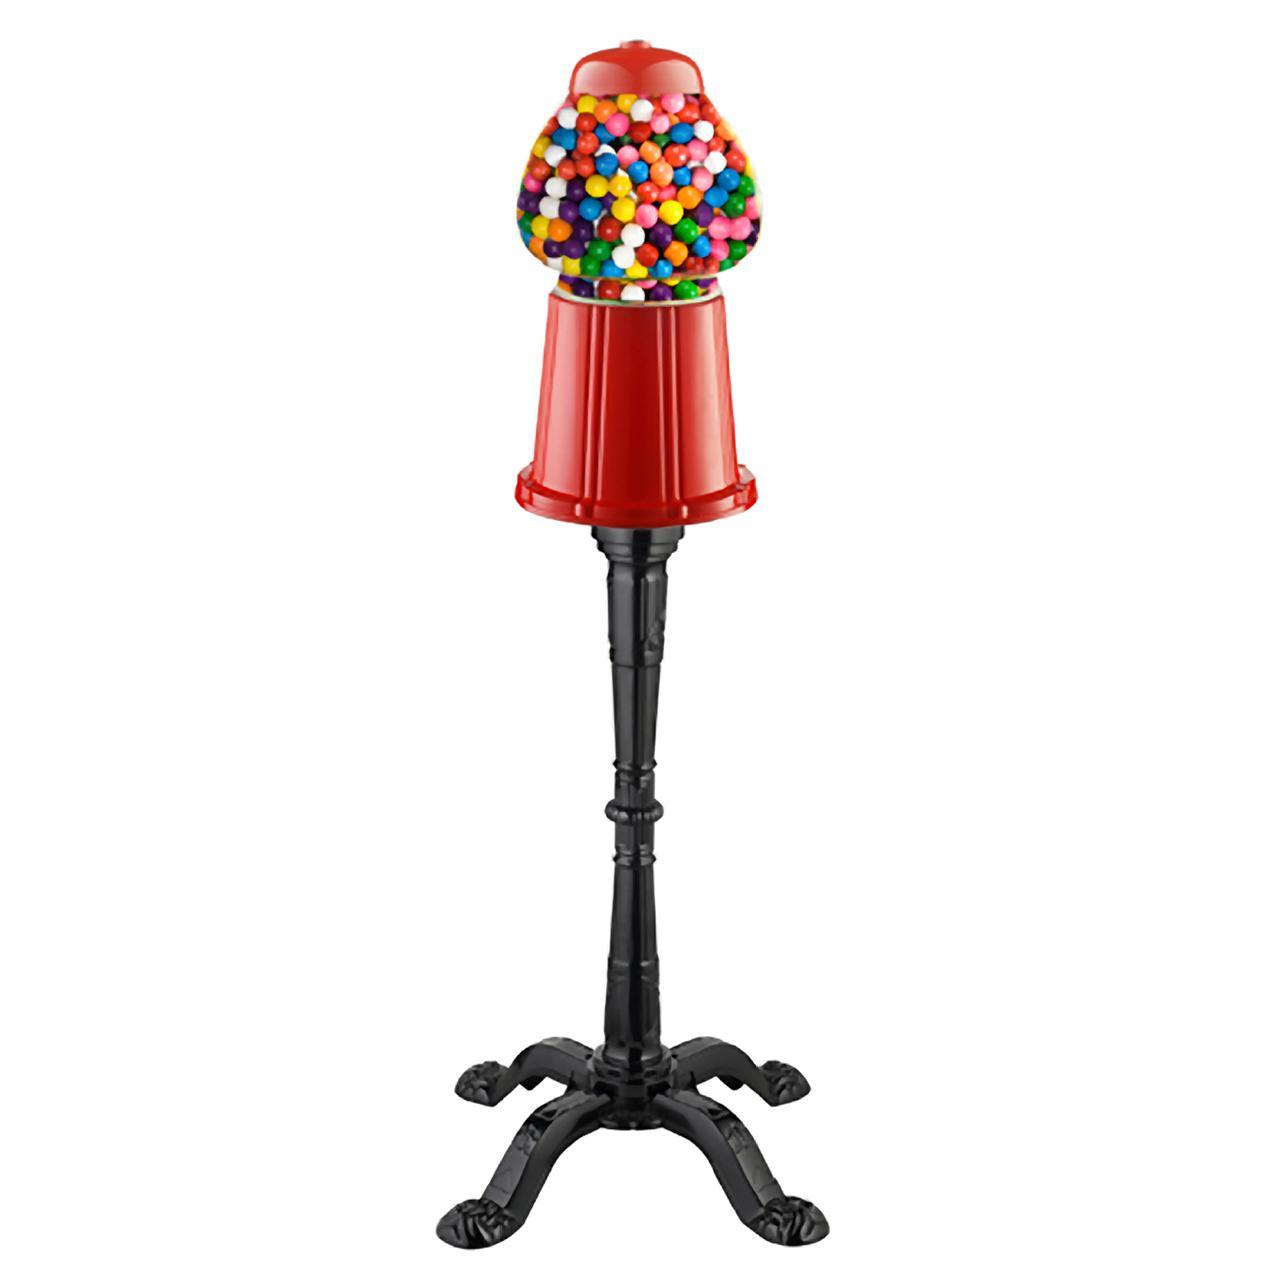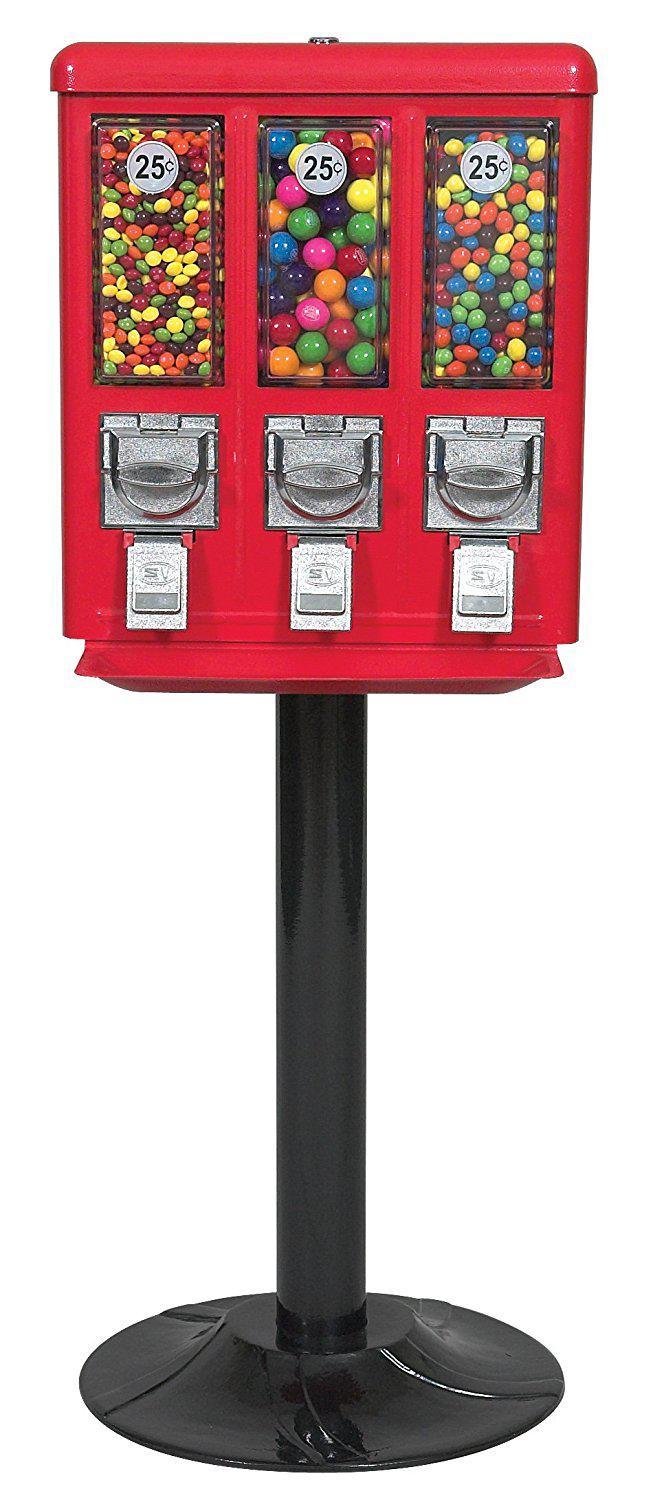The first image is the image on the left, the second image is the image on the right. For the images displayed, is the sentence "There is at least one vending machine that has three total candy compartments." factually correct? Answer yes or no. Yes. 